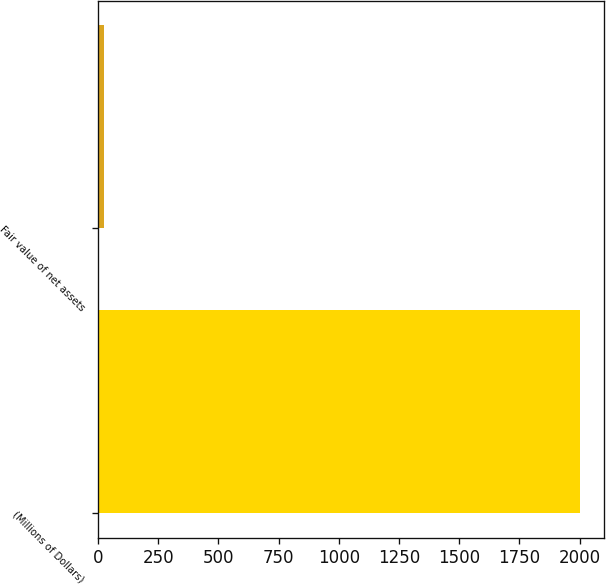Convert chart to OTSL. <chart><loc_0><loc_0><loc_500><loc_500><bar_chart><fcel>(Millions of Dollars)<fcel>Fair value of net assets<nl><fcel>2003<fcel>27<nl></chart> 